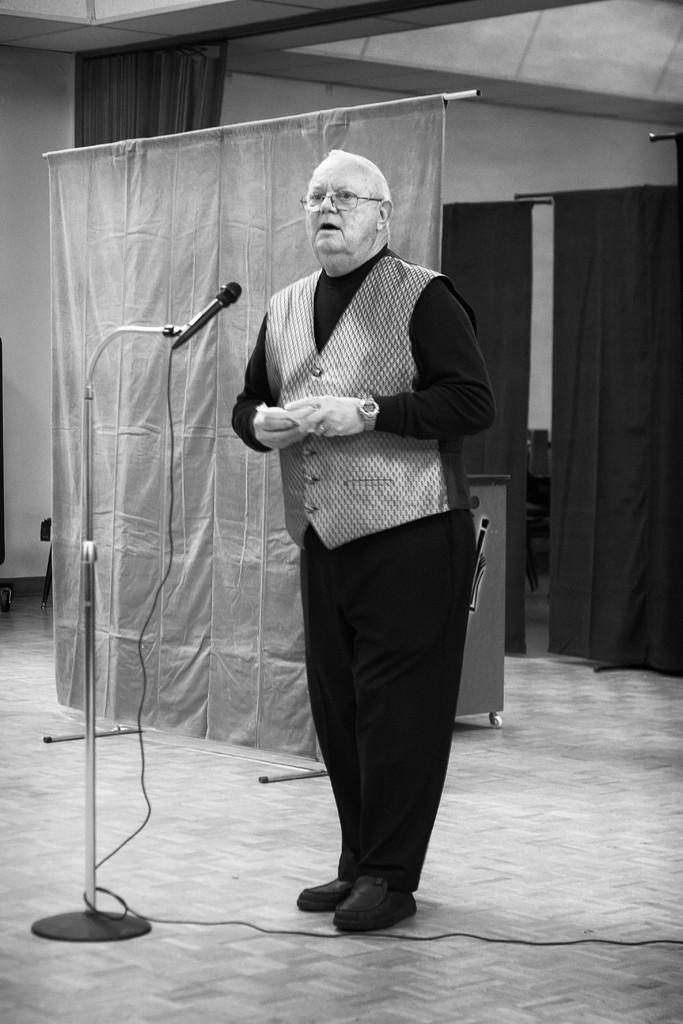What is the main subject of the image? There is a person standing in the image. What is in front of the person? There is a mic and stand in front of the person. What can be seen in the background of the image? There are curtains visible in the background. What is the color scheme of the image? The image is in black and white. What type of lumber is the person holding in the image? There is no lumber present in the image; the person is standing in front of a mic and stand. How old is the person's daughter in the image? There is no daughter present in the image, as it only features a person standing in front of a mic and stand. 